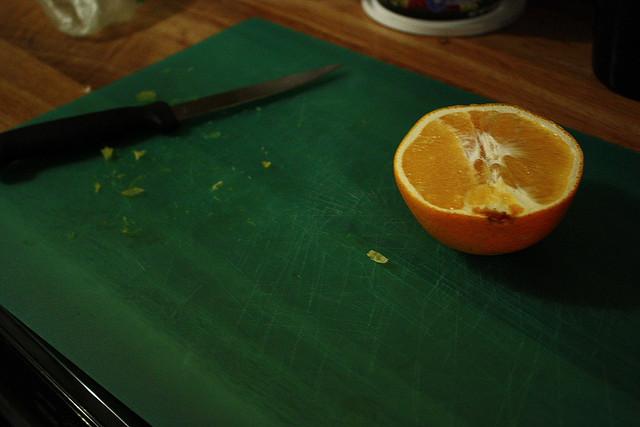What is this fruit especially high in?
Give a very brief answer. Vitamin c. What color is the cutting board?
Concise answer only. Green. Is the food hot?
Concise answer only. No. Is the pith visible?
Concise answer only. Yes. What is the knife handle made of?
Quick response, please. Plastic. What is the orange saying?
Quick response, please. Nothing. IS the knife big or small?
Give a very brief answer. Small. How many slices of orange are there?
Write a very short answer. 1. Is this a dairy free dessert?
Keep it brief. Yes. How many seeds are there?
Keep it brief. 0. How many oranges are there?
Concise answer only. 1. Are fruits essential for a healthy diet?
Concise answer only. Yes. What material is on the table?
Quick response, please. Plastic. What nutrient is this snack rich in?
Quick response, please. Vitamin c. What is the cutting block made of?
Answer briefly. Plastic. What color is the counter?
Write a very short answer. Brown. 